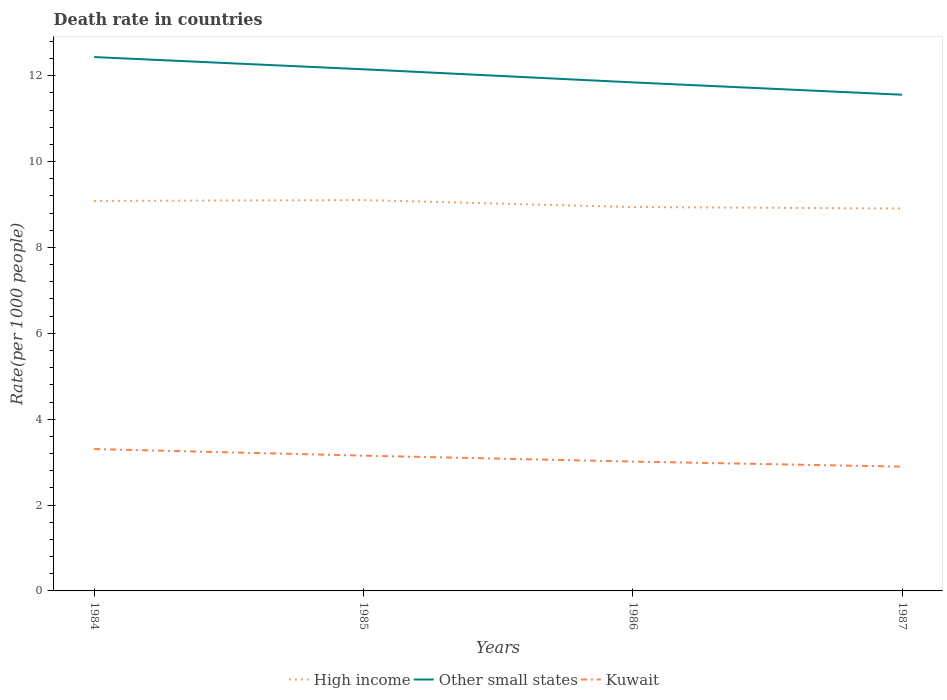Does the line corresponding to Kuwait intersect with the line corresponding to High income?
Provide a short and direct response. No. Across all years, what is the maximum death rate in Kuwait?
Your response must be concise. 2.9. What is the total death rate in High income in the graph?
Your answer should be very brief. 0.16. What is the difference between the highest and the second highest death rate in Kuwait?
Give a very brief answer. 0.41. What is the difference between the highest and the lowest death rate in Kuwait?
Give a very brief answer. 2. Are the values on the major ticks of Y-axis written in scientific E-notation?
Ensure brevity in your answer.  No. Does the graph contain grids?
Provide a succinct answer. No. How are the legend labels stacked?
Give a very brief answer. Horizontal. What is the title of the graph?
Your answer should be very brief. Death rate in countries. Does "Bahrain" appear as one of the legend labels in the graph?
Your answer should be very brief. No. What is the label or title of the Y-axis?
Your response must be concise. Rate(per 1000 people). What is the Rate(per 1000 people) of High income in 1984?
Keep it short and to the point. 9.08. What is the Rate(per 1000 people) of Other small states in 1984?
Provide a succinct answer. 12.43. What is the Rate(per 1000 people) in Kuwait in 1984?
Give a very brief answer. 3.31. What is the Rate(per 1000 people) of High income in 1985?
Ensure brevity in your answer.  9.1. What is the Rate(per 1000 people) of Other small states in 1985?
Offer a terse response. 12.15. What is the Rate(per 1000 people) in Kuwait in 1985?
Make the answer very short. 3.15. What is the Rate(per 1000 people) of High income in 1986?
Your response must be concise. 8.94. What is the Rate(per 1000 people) in Other small states in 1986?
Offer a terse response. 11.84. What is the Rate(per 1000 people) in Kuwait in 1986?
Your response must be concise. 3.01. What is the Rate(per 1000 people) in High income in 1987?
Keep it short and to the point. 8.91. What is the Rate(per 1000 people) in Other small states in 1987?
Provide a succinct answer. 11.56. What is the Rate(per 1000 people) in Kuwait in 1987?
Your answer should be very brief. 2.9. Across all years, what is the maximum Rate(per 1000 people) in High income?
Give a very brief answer. 9.1. Across all years, what is the maximum Rate(per 1000 people) in Other small states?
Provide a short and direct response. 12.43. Across all years, what is the maximum Rate(per 1000 people) in Kuwait?
Ensure brevity in your answer.  3.31. Across all years, what is the minimum Rate(per 1000 people) in High income?
Ensure brevity in your answer.  8.91. Across all years, what is the minimum Rate(per 1000 people) of Other small states?
Give a very brief answer. 11.56. Across all years, what is the minimum Rate(per 1000 people) in Kuwait?
Your answer should be very brief. 2.9. What is the total Rate(per 1000 people) in High income in the graph?
Keep it short and to the point. 36.04. What is the total Rate(per 1000 people) of Other small states in the graph?
Ensure brevity in your answer.  47.99. What is the total Rate(per 1000 people) of Kuwait in the graph?
Your answer should be compact. 12.36. What is the difference between the Rate(per 1000 people) of High income in 1984 and that in 1985?
Make the answer very short. -0.02. What is the difference between the Rate(per 1000 people) of Other small states in 1984 and that in 1985?
Your answer should be very brief. 0.28. What is the difference between the Rate(per 1000 people) of Kuwait in 1984 and that in 1985?
Make the answer very short. 0.15. What is the difference between the Rate(per 1000 people) of High income in 1984 and that in 1986?
Make the answer very short. 0.14. What is the difference between the Rate(per 1000 people) of Other small states in 1984 and that in 1986?
Provide a short and direct response. 0.59. What is the difference between the Rate(per 1000 people) of Kuwait in 1984 and that in 1986?
Your response must be concise. 0.29. What is the difference between the Rate(per 1000 people) of High income in 1984 and that in 1987?
Give a very brief answer. 0.18. What is the difference between the Rate(per 1000 people) of Other small states in 1984 and that in 1987?
Offer a terse response. 0.88. What is the difference between the Rate(per 1000 people) of Kuwait in 1984 and that in 1987?
Offer a very short reply. 0.41. What is the difference between the Rate(per 1000 people) in High income in 1985 and that in 1986?
Make the answer very short. 0.16. What is the difference between the Rate(per 1000 people) in Other small states in 1985 and that in 1986?
Give a very brief answer. 0.31. What is the difference between the Rate(per 1000 people) of Kuwait in 1985 and that in 1986?
Your response must be concise. 0.14. What is the difference between the Rate(per 1000 people) of High income in 1985 and that in 1987?
Provide a short and direct response. 0.2. What is the difference between the Rate(per 1000 people) in Other small states in 1985 and that in 1987?
Your answer should be compact. 0.59. What is the difference between the Rate(per 1000 people) of Kuwait in 1985 and that in 1987?
Give a very brief answer. 0.26. What is the difference between the Rate(per 1000 people) in High income in 1986 and that in 1987?
Ensure brevity in your answer.  0.03. What is the difference between the Rate(per 1000 people) of Other small states in 1986 and that in 1987?
Make the answer very short. 0.29. What is the difference between the Rate(per 1000 people) in Kuwait in 1986 and that in 1987?
Keep it short and to the point. 0.12. What is the difference between the Rate(per 1000 people) of High income in 1984 and the Rate(per 1000 people) of Other small states in 1985?
Make the answer very short. -3.07. What is the difference between the Rate(per 1000 people) of High income in 1984 and the Rate(per 1000 people) of Kuwait in 1985?
Provide a short and direct response. 5.93. What is the difference between the Rate(per 1000 people) of Other small states in 1984 and the Rate(per 1000 people) of Kuwait in 1985?
Your response must be concise. 9.28. What is the difference between the Rate(per 1000 people) of High income in 1984 and the Rate(per 1000 people) of Other small states in 1986?
Your response must be concise. -2.76. What is the difference between the Rate(per 1000 people) in High income in 1984 and the Rate(per 1000 people) in Kuwait in 1986?
Offer a very short reply. 6.07. What is the difference between the Rate(per 1000 people) in Other small states in 1984 and the Rate(per 1000 people) in Kuwait in 1986?
Give a very brief answer. 9.42. What is the difference between the Rate(per 1000 people) of High income in 1984 and the Rate(per 1000 people) of Other small states in 1987?
Make the answer very short. -2.47. What is the difference between the Rate(per 1000 people) in High income in 1984 and the Rate(per 1000 people) in Kuwait in 1987?
Ensure brevity in your answer.  6.19. What is the difference between the Rate(per 1000 people) in Other small states in 1984 and the Rate(per 1000 people) in Kuwait in 1987?
Provide a short and direct response. 9.54. What is the difference between the Rate(per 1000 people) of High income in 1985 and the Rate(per 1000 people) of Other small states in 1986?
Provide a short and direct response. -2.74. What is the difference between the Rate(per 1000 people) of High income in 1985 and the Rate(per 1000 people) of Kuwait in 1986?
Your response must be concise. 6.09. What is the difference between the Rate(per 1000 people) in Other small states in 1985 and the Rate(per 1000 people) in Kuwait in 1986?
Your answer should be very brief. 9.14. What is the difference between the Rate(per 1000 people) of High income in 1985 and the Rate(per 1000 people) of Other small states in 1987?
Your response must be concise. -2.45. What is the difference between the Rate(per 1000 people) of High income in 1985 and the Rate(per 1000 people) of Kuwait in 1987?
Offer a terse response. 6.21. What is the difference between the Rate(per 1000 people) of Other small states in 1985 and the Rate(per 1000 people) of Kuwait in 1987?
Your response must be concise. 9.26. What is the difference between the Rate(per 1000 people) of High income in 1986 and the Rate(per 1000 people) of Other small states in 1987?
Ensure brevity in your answer.  -2.62. What is the difference between the Rate(per 1000 people) of High income in 1986 and the Rate(per 1000 people) of Kuwait in 1987?
Ensure brevity in your answer.  6.05. What is the difference between the Rate(per 1000 people) in Other small states in 1986 and the Rate(per 1000 people) in Kuwait in 1987?
Provide a short and direct response. 8.95. What is the average Rate(per 1000 people) of High income per year?
Keep it short and to the point. 9.01. What is the average Rate(per 1000 people) of Other small states per year?
Make the answer very short. 12. What is the average Rate(per 1000 people) in Kuwait per year?
Provide a succinct answer. 3.09. In the year 1984, what is the difference between the Rate(per 1000 people) of High income and Rate(per 1000 people) of Other small states?
Make the answer very short. -3.35. In the year 1984, what is the difference between the Rate(per 1000 people) in High income and Rate(per 1000 people) in Kuwait?
Offer a very short reply. 5.78. In the year 1984, what is the difference between the Rate(per 1000 people) of Other small states and Rate(per 1000 people) of Kuwait?
Offer a terse response. 9.13. In the year 1985, what is the difference between the Rate(per 1000 people) in High income and Rate(per 1000 people) in Other small states?
Your answer should be compact. -3.05. In the year 1985, what is the difference between the Rate(per 1000 people) in High income and Rate(per 1000 people) in Kuwait?
Provide a short and direct response. 5.95. In the year 1985, what is the difference between the Rate(per 1000 people) in Other small states and Rate(per 1000 people) in Kuwait?
Provide a succinct answer. 9. In the year 1986, what is the difference between the Rate(per 1000 people) in High income and Rate(per 1000 people) in Other small states?
Your answer should be compact. -2.9. In the year 1986, what is the difference between the Rate(per 1000 people) in High income and Rate(per 1000 people) in Kuwait?
Provide a short and direct response. 5.93. In the year 1986, what is the difference between the Rate(per 1000 people) of Other small states and Rate(per 1000 people) of Kuwait?
Provide a short and direct response. 8.83. In the year 1987, what is the difference between the Rate(per 1000 people) in High income and Rate(per 1000 people) in Other small states?
Provide a succinct answer. -2.65. In the year 1987, what is the difference between the Rate(per 1000 people) in High income and Rate(per 1000 people) in Kuwait?
Keep it short and to the point. 6.01. In the year 1987, what is the difference between the Rate(per 1000 people) in Other small states and Rate(per 1000 people) in Kuwait?
Ensure brevity in your answer.  8.66. What is the ratio of the Rate(per 1000 people) in Other small states in 1984 to that in 1985?
Your answer should be very brief. 1.02. What is the ratio of the Rate(per 1000 people) of Kuwait in 1984 to that in 1985?
Give a very brief answer. 1.05. What is the ratio of the Rate(per 1000 people) of High income in 1984 to that in 1986?
Your answer should be compact. 1.02. What is the ratio of the Rate(per 1000 people) in Other small states in 1984 to that in 1986?
Offer a terse response. 1.05. What is the ratio of the Rate(per 1000 people) of Kuwait in 1984 to that in 1986?
Your answer should be compact. 1.1. What is the ratio of the Rate(per 1000 people) of High income in 1984 to that in 1987?
Provide a short and direct response. 1.02. What is the ratio of the Rate(per 1000 people) in Other small states in 1984 to that in 1987?
Your response must be concise. 1.08. What is the ratio of the Rate(per 1000 people) of Kuwait in 1984 to that in 1987?
Your answer should be very brief. 1.14. What is the ratio of the Rate(per 1000 people) of High income in 1985 to that in 1986?
Your answer should be very brief. 1.02. What is the ratio of the Rate(per 1000 people) of Other small states in 1985 to that in 1986?
Your answer should be very brief. 1.03. What is the ratio of the Rate(per 1000 people) in Kuwait in 1985 to that in 1986?
Provide a succinct answer. 1.05. What is the ratio of the Rate(per 1000 people) in High income in 1985 to that in 1987?
Offer a terse response. 1.02. What is the ratio of the Rate(per 1000 people) of Other small states in 1985 to that in 1987?
Your answer should be very brief. 1.05. What is the ratio of the Rate(per 1000 people) in Kuwait in 1985 to that in 1987?
Ensure brevity in your answer.  1.09. What is the ratio of the Rate(per 1000 people) in High income in 1986 to that in 1987?
Your answer should be compact. 1. What is the ratio of the Rate(per 1000 people) of Other small states in 1986 to that in 1987?
Provide a succinct answer. 1.02. What is the ratio of the Rate(per 1000 people) in Kuwait in 1986 to that in 1987?
Your response must be concise. 1.04. What is the difference between the highest and the second highest Rate(per 1000 people) in High income?
Offer a terse response. 0.02. What is the difference between the highest and the second highest Rate(per 1000 people) of Other small states?
Keep it short and to the point. 0.28. What is the difference between the highest and the second highest Rate(per 1000 people) in Kuwait?
Ensure brevity in your answer.  0.15. What is the difference between the highest and the lowest Rate(per 1000 people) of High income?
Your response must be concise. 0.2. What is the difference between the highest and the lowest Rate(per 1000 people) of Other small states?
Make the answer very short. 0.88. What is the difference between the highest and the lowest Rate(per 1000 people) of Kuwait?
Keep it short and to the point. 0.41. 